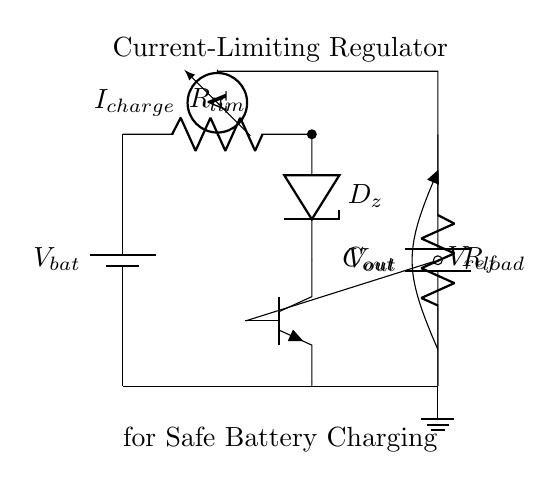What is the type of the main current limiting component? The main current limiting component is a resistor labeled R limiting, which controls the maximum charging current in the circuit.
Answer: R limiting What is the purpose of the Zener diode in this circuit? The Zener diode, labeled D z, is used to maintain a stable reference voltage during charging, preventing over-voltage conditions across the load.
Answer: Reference voltage stabilization What is the value of output voltage shown in the circuit? The output voltage V out is indicated as the voltage drop across the load resistor, but its exact value is not specified in the circuit diagram itself.
Answer: Not specified How many ammeter sensors are present in the circuit? There is one ammeter, as indicated in the circuit which measures the charging current I charge.
Answer: One What does R load represent in this circuit? R load represents the load resistor which the output voltage is supplied to, allowing the device to draw power during operation.
Answer: Load resistor What is the role of the transistor in this circuit? The transistor, labeled Q, functions as a switch that regulates the current flow to the load based on the feedback from the Zener diode and maintains safe charging conditions.
Answer: Current regulation How does the output capacitor influence the circuit performance? The output capacitor, labeled C out, smooths out voltage fluctuations and provides stability during transient responses, ensuring consistent voltage to the load.
Answer: Voltage stability 